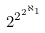<formula> <loc_0><loc_0><loc_500><loc_500>2 ^ { 2 ^ { 2 ^ { \aleph _ { 1 } } } }</formula> 